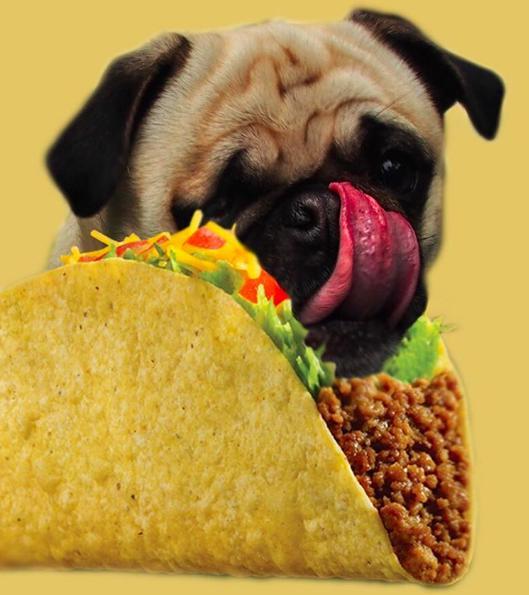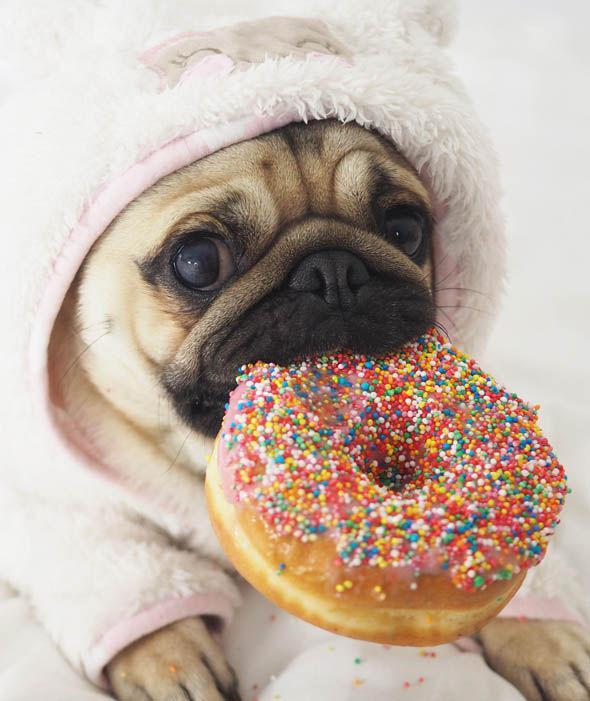The first image is the image on the left, the second image is the image on the right. Analyze the images presented: Is the assertion "The left and right image contains the same number of living pugs." valid? Answer yes or no. Yes. The first image is the image on the left, the second image is the image on the right. For the images shown, is this caption "One of the images is not a living creature." true? Answer yes or no. No. 